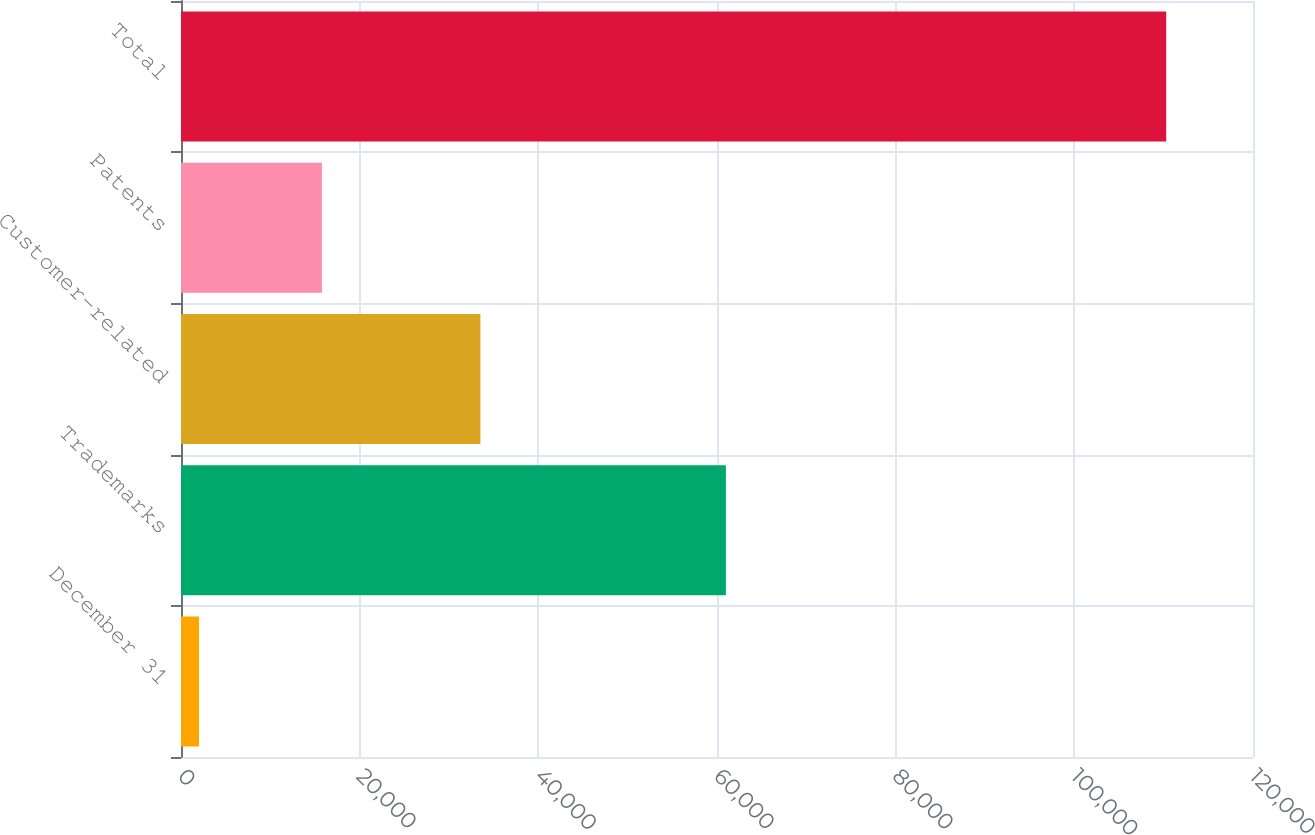Convert chart to OTSL. <chart><loc_0><loc_0><loc_500><loc_500><bar_chart><fcel>December 31<fcel>Trademarks<fcel>Customer-related<fcel>Patents<fcel>Total<nl><fcel>2018<fcel>60995<fcel>33516<fcel>15772<fcel>110283<nl></chart> 